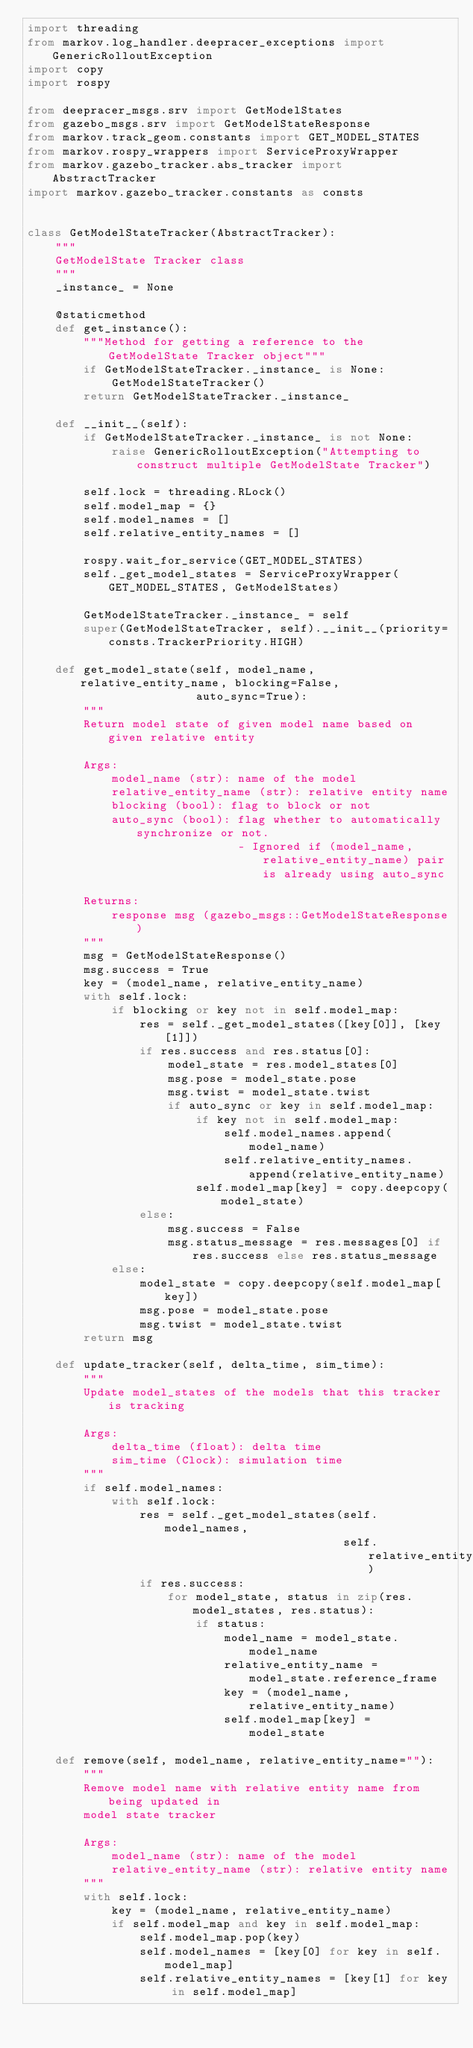<code> <loc_0><loc_0><loc_500><loc_500><_Python_>import threading
from markov.log_handler.deepracer_exceptions import GenericRolloutException
import copy
import rospy

from deepracer_msgs.srv import GetModelStates
from gazebo_msgs.srv import GetModelStateResponse
from markov.track_geom.constants import GET_MODEL_STATES
from markov.rospy_wrappers import ServiceProxyWrapper
from markov.gazebo_tracker.abs_tracker import AbstractTracker
import markov.gazebo_tracker.constants as consts


class GetModelStateTracker(AbstractTracker):
    """
    GetModelState Tracker class
    """
    _instance_ = None

    @staticmethod
    def get_instance():
        """Method for getting a reference to the GetModelState Tracker object"""
        if GetModelStateTracker._instance_ is None:
            GetModelStateTracker()
        return GetModelStateTracker._instance_

    def __init__(self):
        if GetModelStateTracker._instance_ is not None:
            raise GenericRolloutException("Attempting to construct multiple GetModelState Tracker")

        self.lock = threading.RLock()
        self.model_map = {}
        self.model_names = []
        self.relative_entity_names = []

        rospy.wait_for_service(GET_MODEL_STATES)
        self._get_model_states = ServiceProxyWrapper(GET_MODEL_STATES, GetModelStates)

        GetModelStateTracker._instance_ = self
        super(GetModelStateTracker, self).__init__(priority=consts.TrackerPriority.HIGH)

    def get_model_state(self, model_name, relative_entity_name, blocking=False,
                        auto_sync=True):
        """
        Return model state of given model name based on given relative entity

        Args:
            model_name (str): name of the model
            relative_entity_name (str): relative entity name
            blocking (bool): flag to block or not
            auto_sync (bool): flag whether to automatically synchronize or not.
                              - Ignored if (model_name, relative_entity_name) pair is already using auto_sync

        Returns:
            response msg (gazebo_msgs::GetModelStateResponse)
        """
        msg = GetModelStateResponse()
        msg.success = True
        key = (model_name, relative_entity_name)
        with self.lock:
            if blocking or key not in self.model_map:
                res = self._get_model_states([key[0]], [key[1]])
                if res.success and res.status[0]:
                    model_state = res.model_states[0]
                    msg.pose = model_state.pose
                    msg.twist = model_state.twist
                    if auto_sync or key in self.model_map:
                        if key not in self.model_map:
                            self.model_names.append(model_name)
                            self.relative_entity_names.append(relative_entity_name)
                        self.model_map[key] = copy.deepcopy(model_state)
                else:
                    msg.success = False
                    msg.status_message = res.messages[0] if res.success else res.status_message
            else:
                model_state = copy.deepcopy(self.model_map[key])
                msg.pose = model_state.pose
                msg.twist = model_state.twist
        return msg

    def update_tracker(self, delta_time, sim_time):
        """
        Update model_states of the models that this tracker is tracking

        Args:
            delta_time (float): delta time
            sim_time (Clock): simulation time
        """
        if self.model_names:
            with self.lock:
                res = self._get_model_states(self.model_names,
                                             self.relative_entity_names)
                if res.success:
                    for model_state, status in zip(res.model_states, res.status):
                        if status:
                            model_name = model_state.model_name
                            relative_entity_name = model_state.reference_frame
                            key = (model_name, relative_entity_name)
                            self.model_map[key] = model_state

    def remove(self, model_name, relative_entity_name=""):
        """
        Remove model name with relative entity name from being updated in
        model state tracker

        Args:
            model_name (str): name of the model
            relative_entity_name (str): relative entity name
        """
        with self.lock:
            key = (model_name, relative_entity_name)
            if self.model_map and key in self.model_map:
                self.model_map.pop(key)
                self.model_names = [key[0] for key in self.model_map]
                self.relative_entity_names = [key[1] for key in self.model_map]
</code> 